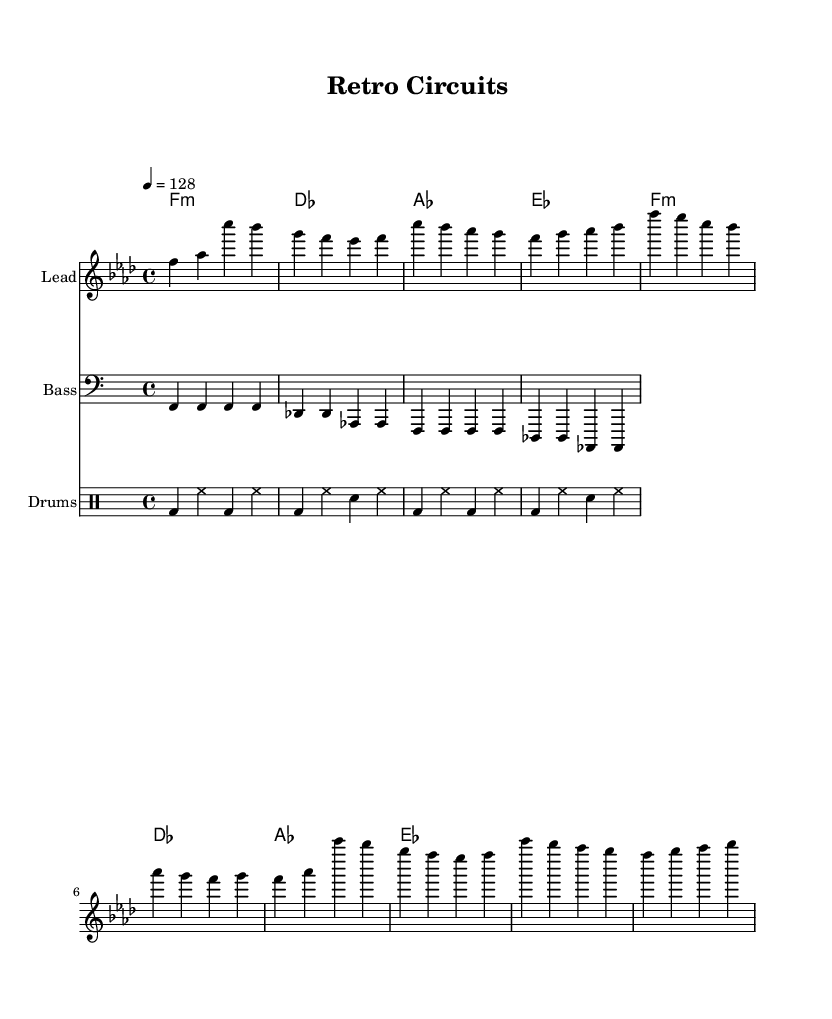What is the key signature of this music? The key signature is indicated at the beginning of the staff, showing four flats. Therefore, the key signature is F minor.
Answer: F minor What is the time signature of this piece? The time signature is notated before the measure, showing a four over four structure. This means there are four beats per measure.
Answer: 4/4 What is the tempo marking for this piece? The tempo marking is indicated in the header of the score, showing a BPM of 128. This tells us the speed of the music.
Answer: 128 How many measures are there in the melody section? By counting the measures in the melody part, which contains two sections of eight measures each, we get a total of sixteen measures in the melody.
Answer: 16 What chord is used in the first measure of the harmony? The chord in the first measure is shown as F minor, represented with "f1:m" in the chord staff.
Answer: F minor What is the primary characteristic of the bassline in this piece? The bassline consists of repetitive notes, specifically F and D flat in the first half, which gives a solid foundation typical of dance music.
Answer: Repetitive notes Which electronic rhythm instrument appears in the drum section? The drum section has rhythm notes such as "bd" for bass drum and "sn" for snare, indicating different electronic percussion elements.
Answer: Bass drum 